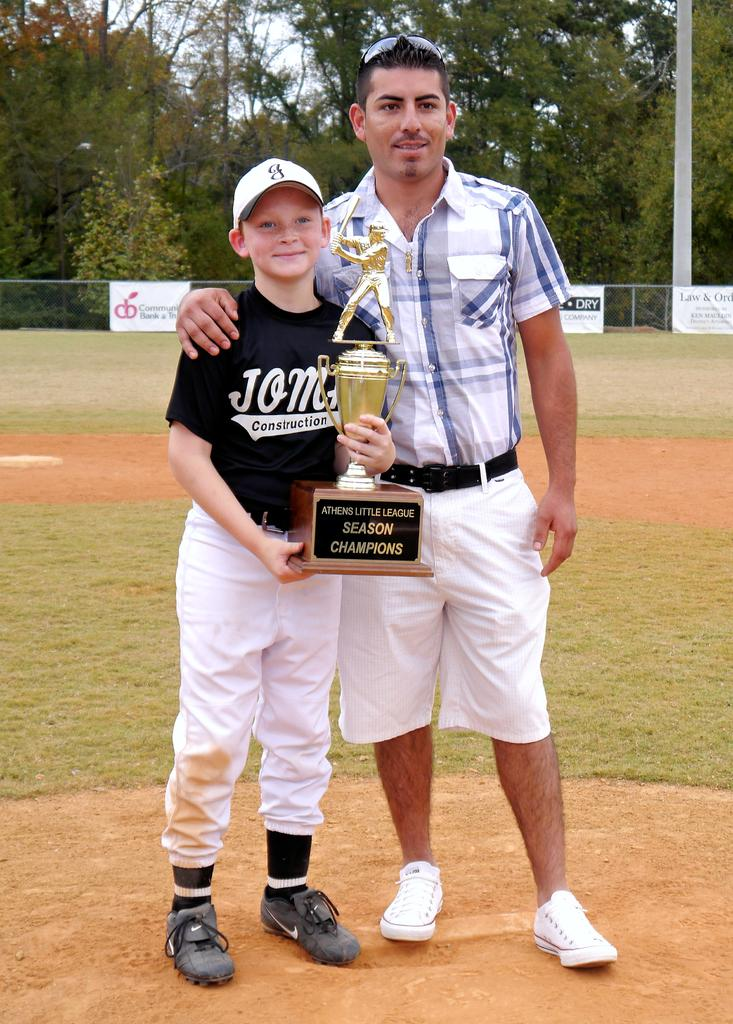Provide a one-sentence caption for the provided image. a man and boy holding a Season Champions baseball trophy. 